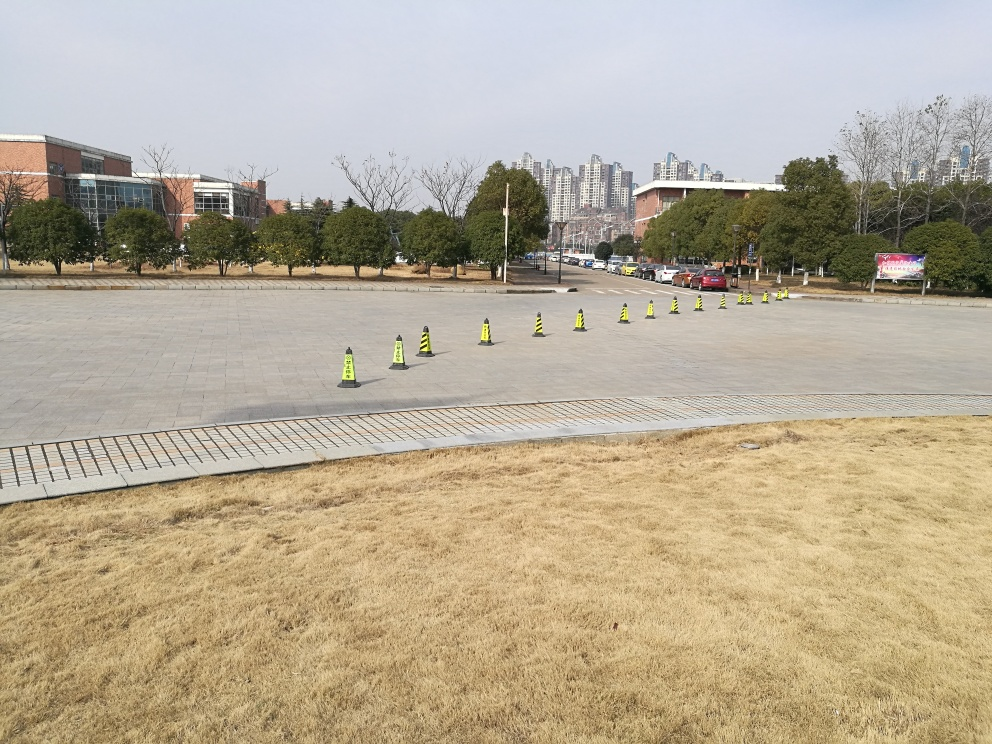Can you tell me about the environment surrounding the cones? The cones are situated in a wide, expansive plaza characterized by large paved areas. This provides ample space for gatherings or events. The environment includes grassy patches, trees in the background, and modern buildings which indicate the space is likely part of a campus or a public area designed for both aesthetic appeal and functional use. 